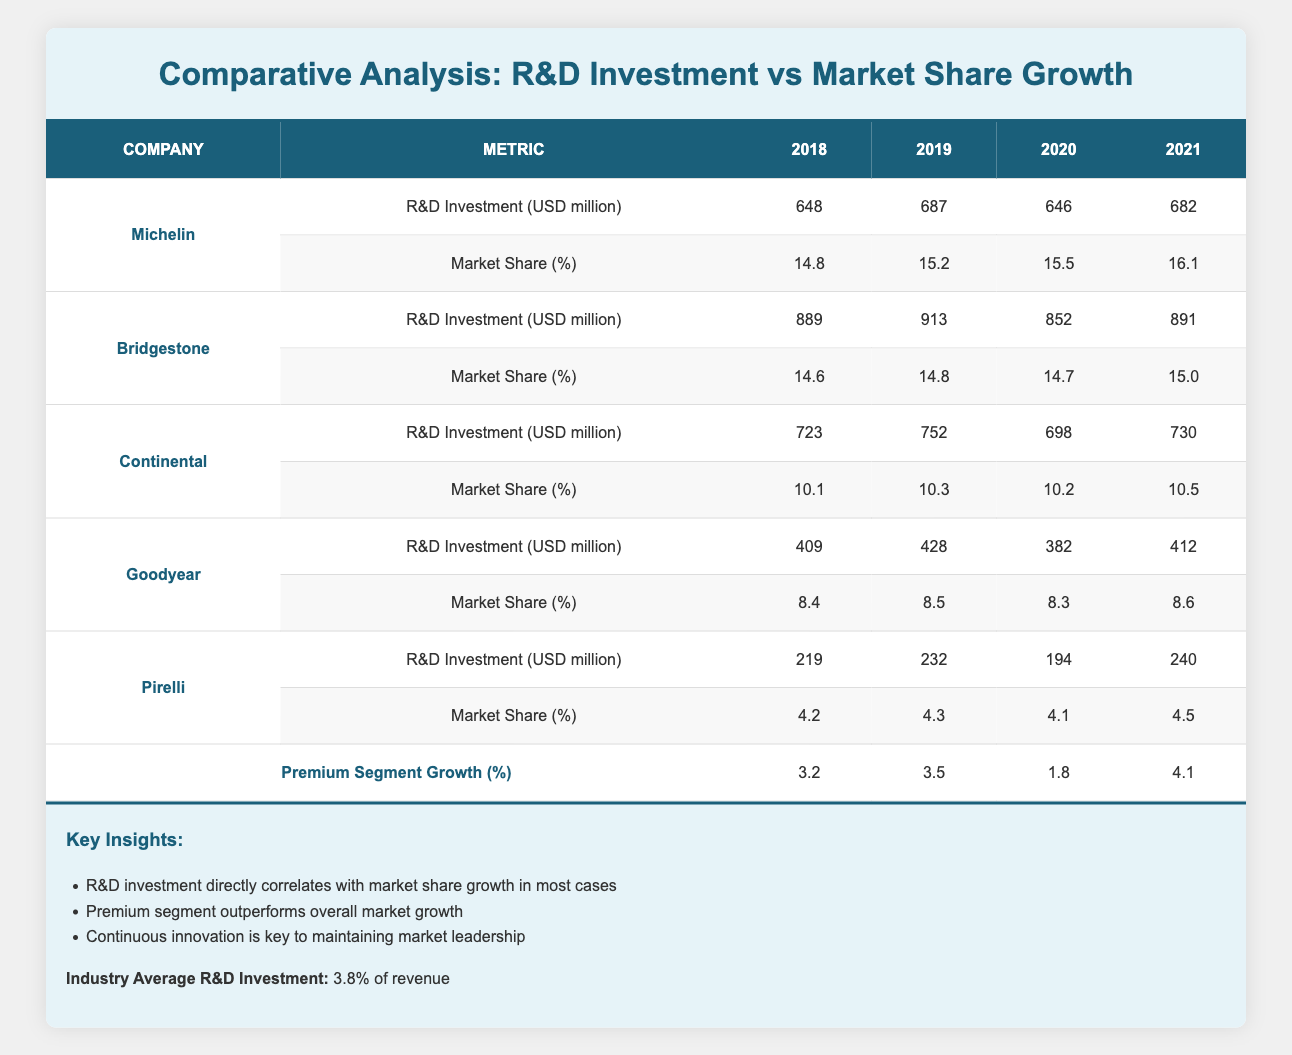What was Michelin's R&D investment in 2019? From the table, Michelin's R&D investment for 2019 is listed directly under the corresponding column for that year, which shows 687 million USD.
Answer: 687 million USD What was the market share of Pirelli in 2021? The table indicates that Pirelli's market share in 2021 is shown in the corresponding row, which is 4.5%.
Answer: 4.5% Which company had the highest R&D investment in 2020? Reviewing the R&D investments for 2020 across all companies, Bridgestone has the highest value listed at 852 million USD.
Answer: Bridgestone Calculate the average market share for Continental from 2018 to 2021. To find the average, sum the market share values for Continental over the years 2018 (10.1%), 2019 (10.3%), 2020 (10.2%), and 2021 (10.5%). The sum is (10.1 + 10.3 + 10.2 + 10.5) = 41.1%, and dividing by 4 gives an average of 10.275%.
Answer: 10.275% Is Goodyear's market share in 2020 greater than its market share in 2019? Looking at the table, Goodyear's market share is 8.5% in 2019 and 8.3% in 2020. Since 8.5% is greater than 8.3%, the statement is false.
Answer: No What is the total R&D investment for Michelin between 2018 and 2021? To find the total, add Michelin's R&D investments: 648 (2018) + 687 (2019) + 646 (2020) + 682 (2021) = 2,663 million USD.
Answer: 2,663 million USD Did Bridgestone's market share increase every year from 2018 to 2021? From the market share values for Bridgestone, 14.6% in 2018, 14.8% in 2019, 14.7% in 2020, and 15.0% in 2021 show that it increased in 2019, decreased in 2020, and then increased again in 2021; thus, not every year saw an increase.
Answer: No Which company saw the largest increase in market share from 2020 to 2021? Looking at the market share differences from 2020 to 2021, Michelin increased from 15.5% to 16.1% (+0.6%), and Continental grew from 10.2% to 10.5% (+0.3%), while other companies either declined or showed smaller increases. Thus, Michelin had the largest increase.
Answer: Michelin 